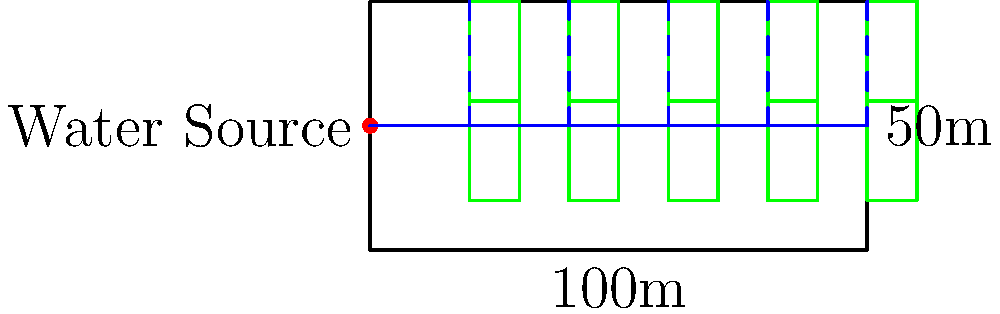Design an efficient irrigation system for a 100m x 50m rectangular farm with a water source located at the midpoint of the left side. The farm has 10 equally sized crop areas arranged in two rows. Calculate the total length of piping needed if the main pipe runs horizontally from the water source to the opposite end, with five vertical branches supplying water to each pair of crop areas. Let's break this down step-by-step:

1. Main pipe length:
   The main pipe runs the entire length of the farm.
   Length of main pipe = 100m

2. Branch pipes:
   There are 5 branch pipes, each running from the main pipe to the top of the farm.
   Length of each branch = 50m - 25m = 25m (since the main pipe is at the midpoint)
   Total length of branch pipes = 5 * 25m = 125m

3. Total piping length:
   Total = Main pipe + Branch pipes
   Total = 100m + 125m = 225m

Therefore, the total length of piping needed for this irrigation system is 225 meters.
Answer: 225 meters 